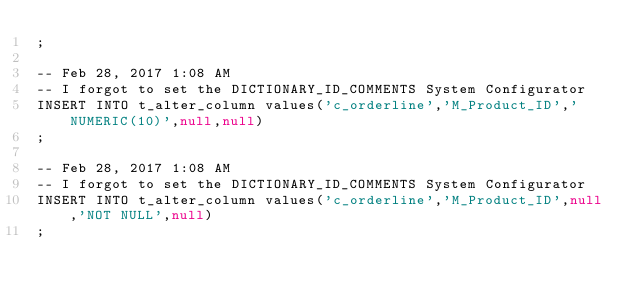<code> <loc_0><loc_0><loc_500><loc_500><_SQL_>;

-- Feb 28, 2017 1:08 AM
-- I forgot to set the DICTIONARY_ID_COMMENTS System Configurator
INSERT INTO t_alter_column values('c_orderline','M_Product_ID','NUMERIC(10)',null,null)
;

-- Feb 28, 2017 1:08 AM
-- I forgot to set the DICTIONARY_ID_COMMENTS System Configurator
INSERT INTO t_alter_column values('c_orderline','M_Product_ID',null,'NOT NULL',null)
;

</code> 